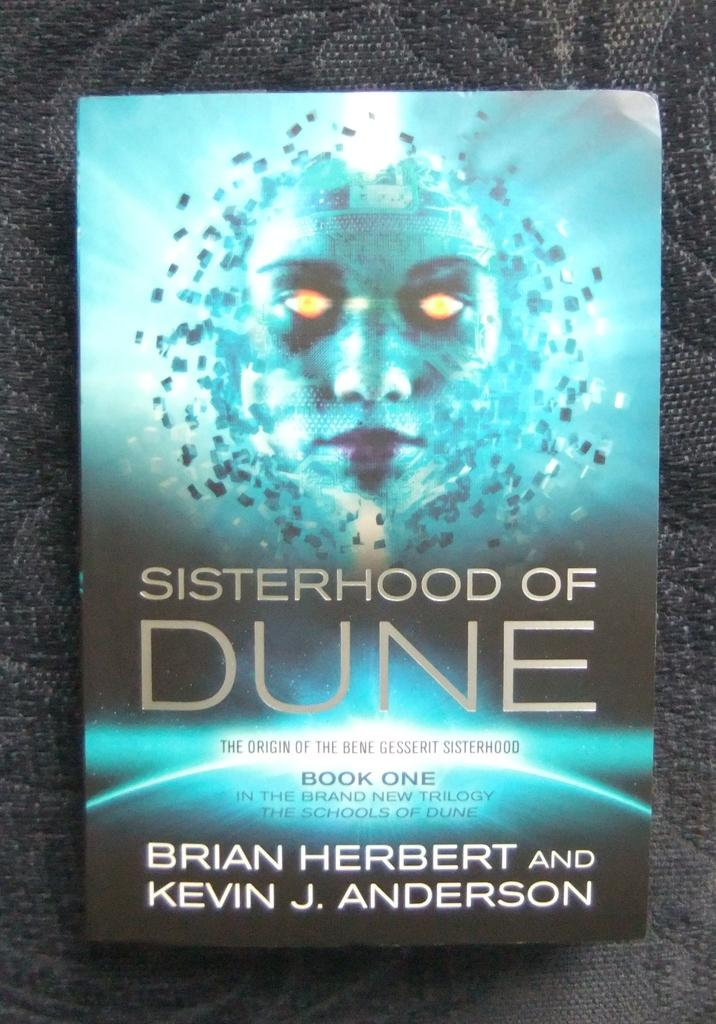<image>
Offer a succinct explanation of the picture presented. A paperback copy of the Sisterhood of Dune 